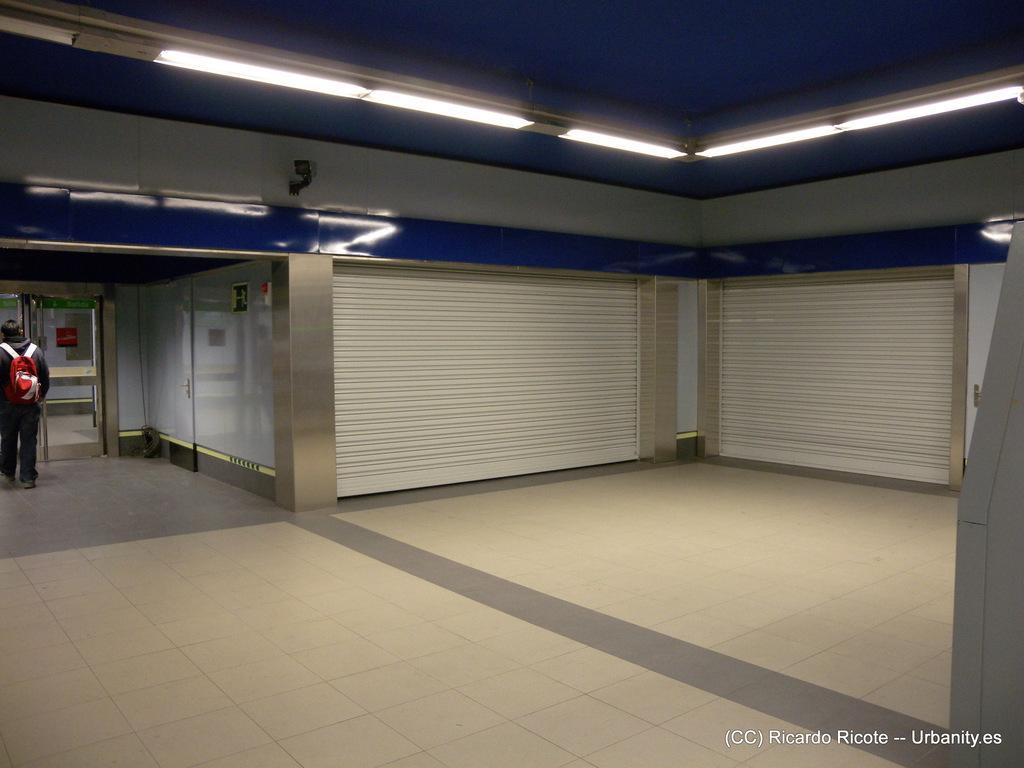Could you give a brief overview of what you see in this image? This is a inside picture of a building. In this image we can see shutters. There is a person to the left side of the image. At the top of the image there is ceiling with lights. At the bottom of the image there is floor. There is some text. 